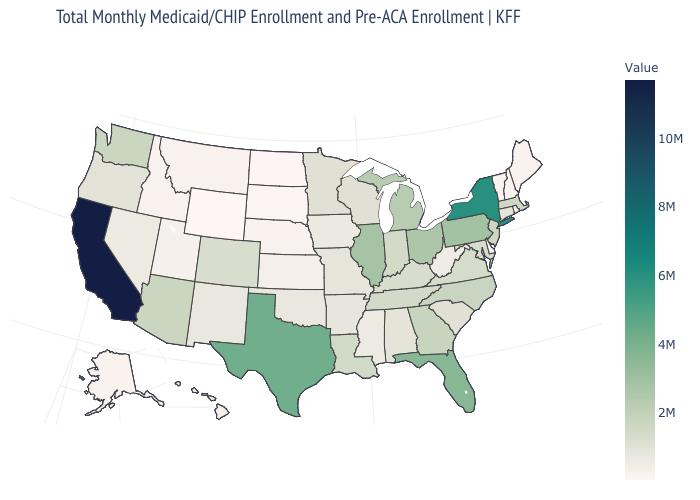Does California have the highest value in the USA?
Write a very short answer. Yes. Does Texas have a higher value than California?
Answer briefly. No. Which states have the lowest value in the West?
Keep it brief. Wyoming. Does Washington have a higher value than Pennsylvania?
Short answer required. No. 